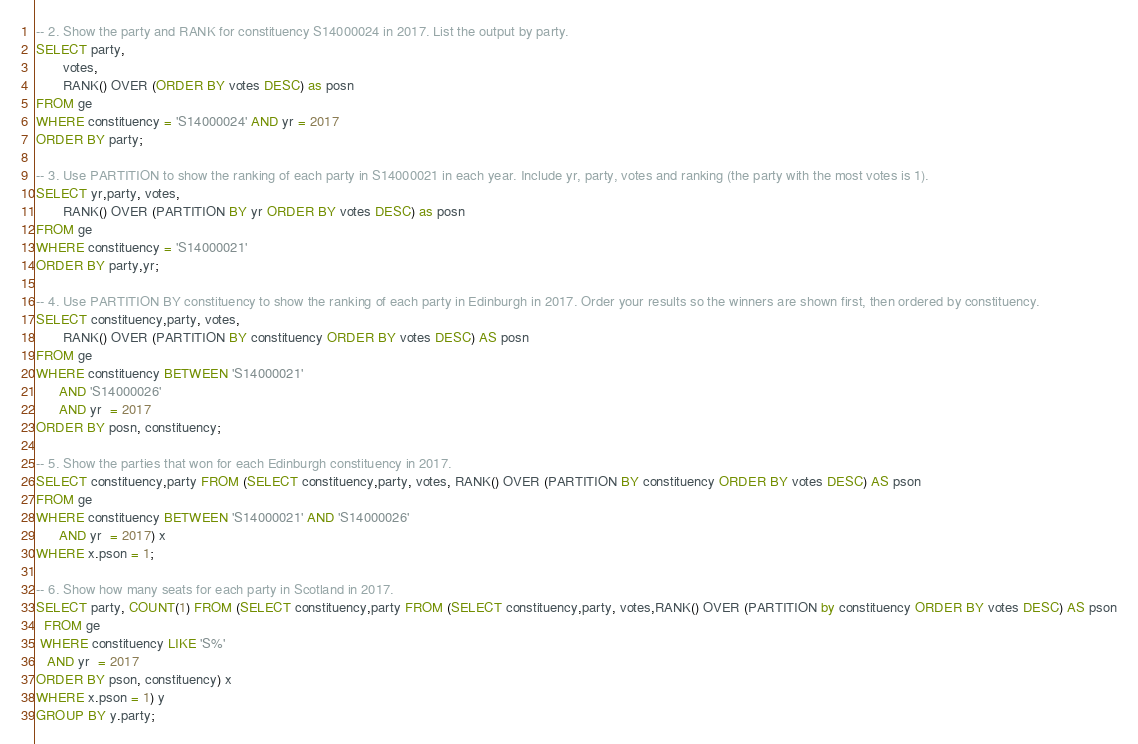<code> <loc_0><loc_0><loc_500><loc_500><_SQL_>-- 2. Show the party and RANK for constituency S14000024 in 2017. List the output by party.
SELECT party,
       votes,
       RANK() OVER (ORDER BY votes DESC) as posn
FROM ge
WHERE constituency = 'S14000024' AND yr = 2017
ORDER BY party;

-- 3. Use PARTITION to show the ranking of each party in S14000021 in each year. Include yr, party, votes and ranking (the party with the most votes is 1).
SELECT yr,party, votes,
       RANK() OVER (PARTITION BY yr ORDER BY votes DESC) as posn
FROM ge
WHERE constituency = 'S14000021'
ORDER BY party,yr;

-- 4. Use PARTITION BY constituency to show the ranking of each party in Edinburgh in 2017. Order your results so the winners are shown first, then ordered by constituency.
SELECT constituency,party, votes,
       RANK() OVER (PARTITION BY constituency ORDER BY votes DESC) AS posn
FROM ge
WHERE constituency BETWEEN 'S14000021'
      AND 'S14000026'
      AND yr  = 2017
ORDER BY posn, constituency;

-- 5. Show the parties that won for each Edinburgh constituency in 2017.
SELECT constituency,party FROM (SELECT constituency,party, votes, RANK() OVER (PARTITION BY constituency ORDER BY votes DESC) AS pson
FROM ge
WHERE constituency BETWEEN 'S14000021' AND 'S14000026'
      AND yr  = 2017) x
WHERE x.pson = 1;

-- 6. Show how many seats for each party in Scotland in 2017.
SELECT party, COUNT(1) FROM (SELECT constituency,party FROM (SELECT constituency,party, votes,RANK() OVER (PARTITION by constituency ORDER BY votes DESC) AS pson
  FROM ge
 WHERE constituency LIKE 'S%'
   AND yr  = 2017
ORDER BY pson, constituency) x
WHERE x.pson = 1) y
GROUP BY y.party;
</code> 